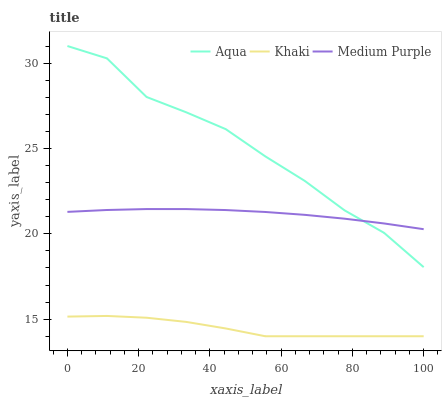Does Khaki have the minimum area under the curve?
Answer yes or no. Yes. Does Aqua have the maximum area under the curve?
Answer yes or no. Yes. Does Aqua have the minimum area under the curve?
Answer yes or no. No. Does Khaki have the maximum area under the curve?
Answer yes or no. No. Is Medium Purple the smoothest?
Answer yes or no. Yes. Is Aqua the roughest?
Answer yes or no. Yes. Is Khaki the smoothest?
Answer yes or no. No. Is Khaki the roughest?
Answer yes or no. No. Does Khaki have the lowest value?
Answer yes or no. Yes. Does Aqua have the lowest value?
Answer yes or no. No. Does Aqua have the highest value?
Answer yes or no. Yes. Does Khaki have the highest value?
Answer yes or no. No. Is Khaki less than Aqua?
Answer yes or no. Yes. Is Aqua greater than Khaki?
Answer yes or no. Yes. Does Medium Purple intersect Aqua?
Answer yes or no. Yes. Is Medium Purple less than Aqua?
Answer yes or no. No. Is Medium Purple greater than Aqua?
Answer yes or no. No. Does Khaki intersect Aqua?
Answer yes or no. No. 